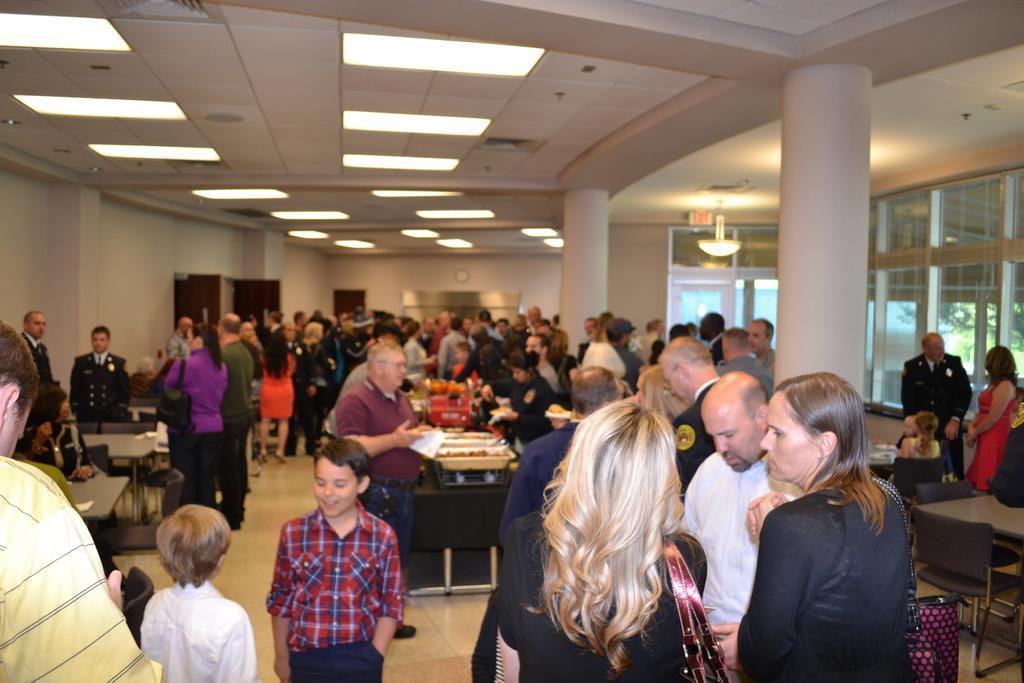Describe this image in one or two sentences. This picture is inside view of a room. We can see tables, chairs and group of people are present. On the table we can see some objects, containers are present. At the bottom of the image we can see some persons are wearing bag. At the top of the image we can see roof, lights are present. On the right side of the image we can see pillars, window, glass are there. At the bottom of the image floor is there. 